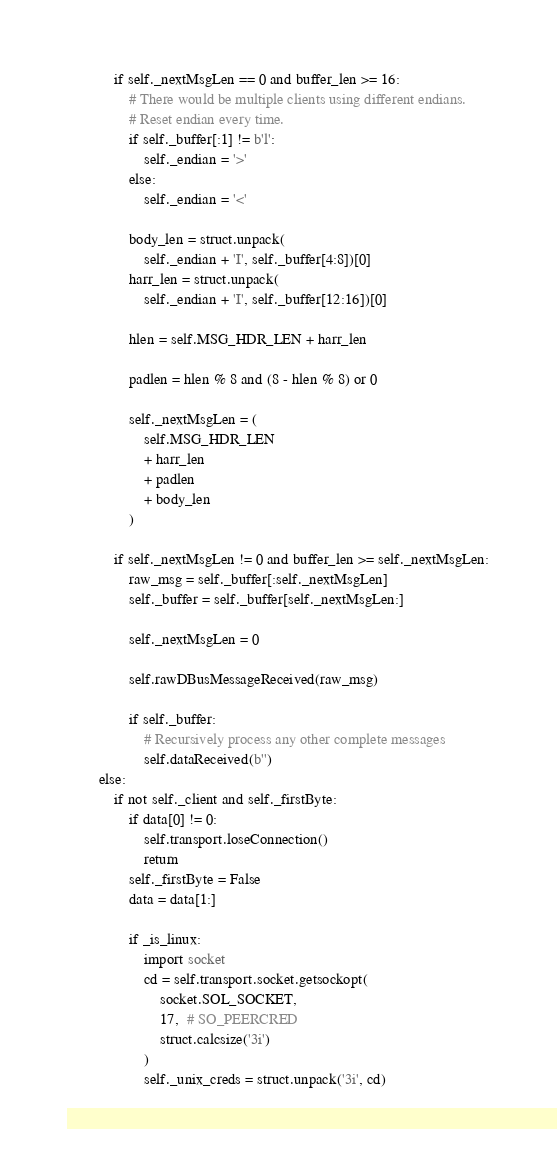Convert code to text. <code><loc_0><loc_0><loc_500><loc_500><_Python_>            if self._nextMsgLen == 0 and buffer_len >= 16:
                # There would be multiple clients using different endians.
                # Reset endian every time.
                if self._buffer[:1] != b'l':
                    self._endian = '>'
                else:
                    self._endian = '<'

                body_len = struct.unpack(
                    self._endian + 'I', self._buffer[4:8])[0]
                harr_len = struct.unpack(
                    self._endian + 'I', self._buffer[12:16])[0]

                hlen = self.MSG_HDR_LEN + harr_len

                padlen = hlen % 8 and (8 - hlen % 8) or 0

                self._nextMsgLen = (
                    self.MSG_HDR_LEN
                    + harr_len
                    + padlen
                    + body_len
                )

            if self._nextMsgLen != 0 and buffer_len >= self._nextMsgLen:
                raw_msg = self._buffer[:self._nextMsgLen]
                self._buffer = self._buffer[self._nextMsgLen:]

                self._nextMsgLen = 0

                self.rawDBusMessageReceived(raw_msg)

                if self._buffer:
                    # Recursively process any other complete messages
                    self.dataReceived(b'')
        else:
            if not self._client and self._firstByte:
                if data[0] != 0:
                    self.transport.loseConnection()
                    return
                self._firstByte = False
                data = data[1:]

                if _is_linux:
                    import socket
                    cd = self.transport.socket.getsockopt(
                        socket.SOL_SOCKET,
                        17,  # SO_PEERCRED
                        struct.calcsize('3i')
                    )
                    self._unix_creds = struct.unpack('3i', cd)
</code> 